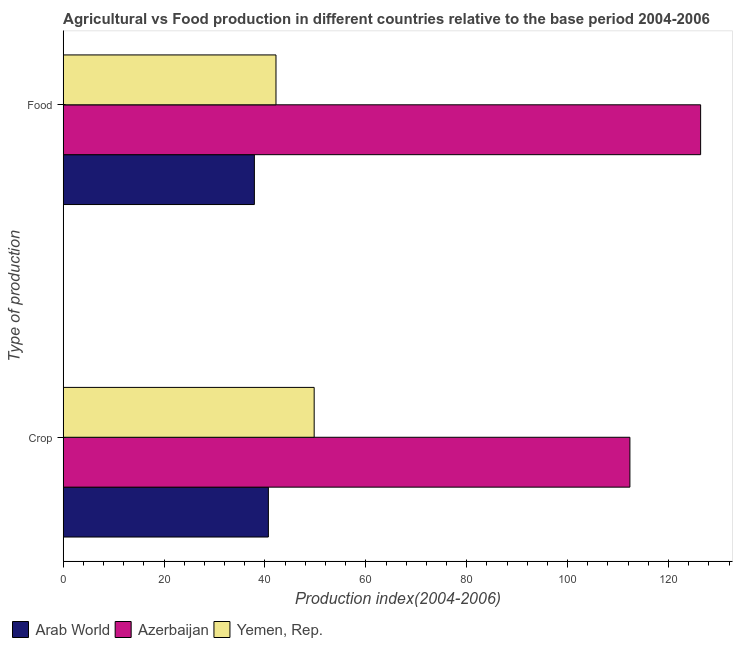Are the number of bars per tick equal to the number of legend labels?
Give a very brief answer. Yes. Are the number of bars on each tick of the Y-axis equal?
Provide a short and direct response. Yes. How many bars are there on the 2nd tick from the bottom?
Provide a succinct answer. 3. What is the label of the 1st group of bars from the top?
Your response must be concise. Food. What is the crop production index in Yemen, Rep.?
Offer a very short reply. 49.75. Across all countries, what is the maximum food production index?
Provide a short and direct response. 126.37. Across all countries, what is the minimum crop production index?
Your answer should be compact. 40.67. In which country was the food production index maximum?
Make the answer very short. Azerbaijan. In which country was the crop production index minimum?
Ensure brevity in your answer.  Arab World. What is the total crop production index in the graph?
Ensure brevity in your answer.  202.77. What is the difference between the crop production index in Arab World and that in Azerbaijan?
Provide a succinct answer. -71.68. What is the difference between the crop production index in Yemen, Rep. and the food production index in Azerbaijan?
Offer a terse response. -76.62. What is the average crop production index per country?
Your answer should be compact. 67.59. What is the difference between the crop production index and food production index in Arab World?
Your response must be concise. 2.78. In how many countries, is the crop production index greater than 20 ?
Give a very brief answer. 3. What is the ratio of the food production index in Yemen, Rep. to that in Azerbaijan?
Ensure brevity in your answer.  0.33. What does the 3rd bar from the top in Food represents?
Keep it short and to the point. Arab World. What does the 1st bar from the bottom in Crop represents?
Give a very brief answer. Arab World. Does the graph contain grids?
Offer a terse response. No. How many legend labels are there?
Make the answer very short. 3. What is the title of the graph?
Offer a very short reply. Agricultural vs Food production in different countries relative to the base period 2004-2006. Does "Iceland" appear as one of the legend labels in the graph?
Offer a very short reply. No. What is the label or title of the X-axis?
Your response must be concise. Production index(2004-2006). What is the label or title of the Y-axis?
Provide a short and direct response. Type of production. What is the Production index(2004-2006) of Arab World in Crop?
Your answer should be compact. 40.67. What is the Production index(2004-2006) in Azerbaijan in Crop?
Provide a short and direct response. 112.35. What is the Production index(2004-2006) in Yemen, Rep. in Crop?
Ensure brevity in your answer.  49.75. What is the Production index(2004-2006) in Arab World in Food?
Your response must be concise. 37.9. What is the Production index(2004-2006) of Azerbaijan in Food?
Give a very brief answer. 126.37. What is the Production index(2004-2006) of Yemen, Rep. in Food?
Make the answer very short. 42.18. Across all Type of production, what is the maximum Production index(2004-2006) in Arab World?
Your response must be concise. 40.67. Across all Type of production, what is the maximum Production index(2004-2006) of Azerbaijan?
Provide a short and direct response. 126.37. Across all Type of production, what is the maximum Production index(2004-2006) in Yemen, Rep.?
Make the answer very short. 49.75. Across all Type of production, what is the minimum Production index(2004-2006) in Arab World?
Keep it short and to the point. 37.9. Across all Type of production, what is the minimum Production index(2004-2006) in Azerbaijan?
Offer a very short reply. 112.35. Across all Type of production, what is the minimum Production index(2004-2006) of Yemen, Rep.?
Ensure brevity in your answer.  42.18. What is the total Production index(2004-2006) of Arab World in the graph?
Ensure brevity in your answer.  78.57. What is the total Production index(2004-2006) of Azerbaijan in the graph?
Offer a very short reply. 238.72. What is the total Production index(2004-2006) in Yemen, Rep. in the graph?
Give a very brief answer. 91.93. What is the difference between the Production index(2004-2006) in Arab World in Crop and that in Food?
Provide a succinct answer. 2.78. What is the difference between the Production index(2004-2006) in Azerbaijan in Crop and that in Food?
Offer a very short reply. -14.02. What is the difference between the Production index(2004-2006) of Yemen, Rep. in Crop and that in Food?
Give a very brief answer. 7.57. What is the difference between the Production index(2004-2006) of Arab World in Crop and the Production index(2004-2006) of Azerbaijan in Food?
Your answer should be compact. -85.7. What is the difference between the Production index(2004-2006) of Arab World in Crop and the Production index(2004-2006) of Yemen, Rep. in Food?
Your response must be concise. -1.51. What is the difference between the Production index(2004-2006) in Azerbaijan in Crop and the Production index(2004-2006) in Yemen, Rep. in Food?
Offer a terse response. 70.17. What is the average Production index(2004-2006) of Arab World per Type of production?
Your answer should be compact. 39.28. What is the average Production index(2004-2006) in Azerbaijan per Type of production?
Keep it short and to the point. 119.36. What is the average Production index(2004-2006) in Yemen, Rep. per Type of production?
Ensure brevity in your answer.  45.97. What is the difference between the Production index(2004-2006) of Arab World and Production index(2004-2006) of Azerbaijan in Crop?
Keep it short and to the point. -71.68. What is the difference between the Production index(2004-2006) in Arab World and Production index(2004-2006) in Yemen, Rep. in Crop?
Provide a short and direct response. -9.08. What is the difference between the Production index(2004-2006) of Azerbaijan and Production index(2004-2006) of Yemen, Rep. in Crop?
Give a very brief answer. 62.6. What is the difference between the Production index(2004-2006) in Arab World and Production index(2004-2006) in Azerbaijan in Food?
Make the answer very short. -88.47. What is the difference between the Production index(2004-2006) of Arab World and Production index(2004-2006) of Yemen, Rep. in Food?
Your answer should be compact. -4.28. What is the difference between the Production index(2004-2006) in Azerbaijan and Production index(2004-2006) in Yemen, Rep. in Food?
Provide a succinct answer. 84.19. What is the ratio of the Production index(2004-2006) of Arab World in Crop to that in Food?
Give a very brief answer. 1.07. What is the ratio of the Production index(2004-2006) of Azerbaijan in Crop to that in Food?
Offer a very short reply. 0.89. What is the ratio of the Production index(2004-2006) of Yemen, Rep. in Crop to that in Food?
Offer a very short reply. 1.18. What is the difference between the highest and the second highest Production index(2004-2006) of Arab World?
Give a very brief answer. 2.78. What is the difference between the highest and the second highest Production index(2004-2006) of Azerbaijan?
Your answer should be compact. 14.02. What is the difference between the highest and the second highest Production index(2004-2006) of Yemen, Rep.?
Keep it short and to the point. 7.57. What is the difference between the highest and the lowest Production index(2004-2006) in Arab World?
Provide a succinct answer. 2.78. What is the difference between the highest and the lowest Production index(2004-2006) of Azerbaijan?
Make the answer very short. 14.02. What is the difference between the highest and the lowest Production index(2004-2006) in Yemen, Rep.?
Keep it short and to the point. 7.57. 